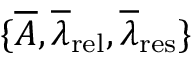Convert formula to latex. <formula><loc_0><loc_0><loc_500><loc_500>\{ \overline { A } , \overline { \lambda } _ { r e l } , \overline { \lambda } _ { r e s } \}</formula> 